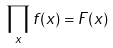<formula> <loc_0><loc_0><loc_500><loc_500>\prod _ { x } f ( x ) = F ( x )</formula> 